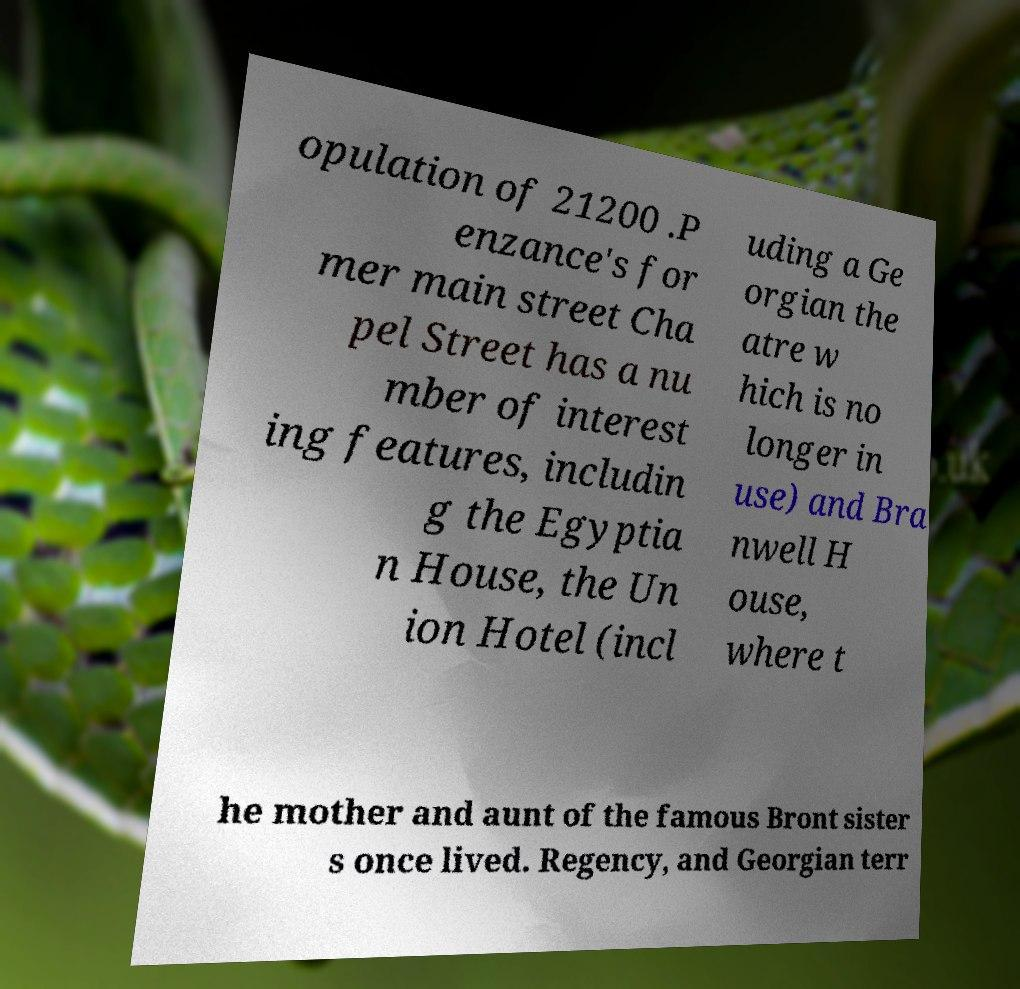For documentation purposes, I need the text within this image transcribed. Could you provide that? opulation of 21200 .P enzance's for mer main street Cha pel Street has a nu mber of interest ing features, includin g the Egyptia n House, the Un ion Hotel (incl uding a Ge orgian the atre w hich is no longer in use) and Bra nwell H ouse, where t he mother and aunt of the famous Bront sister s once lived. Regency, and Georgian terr 